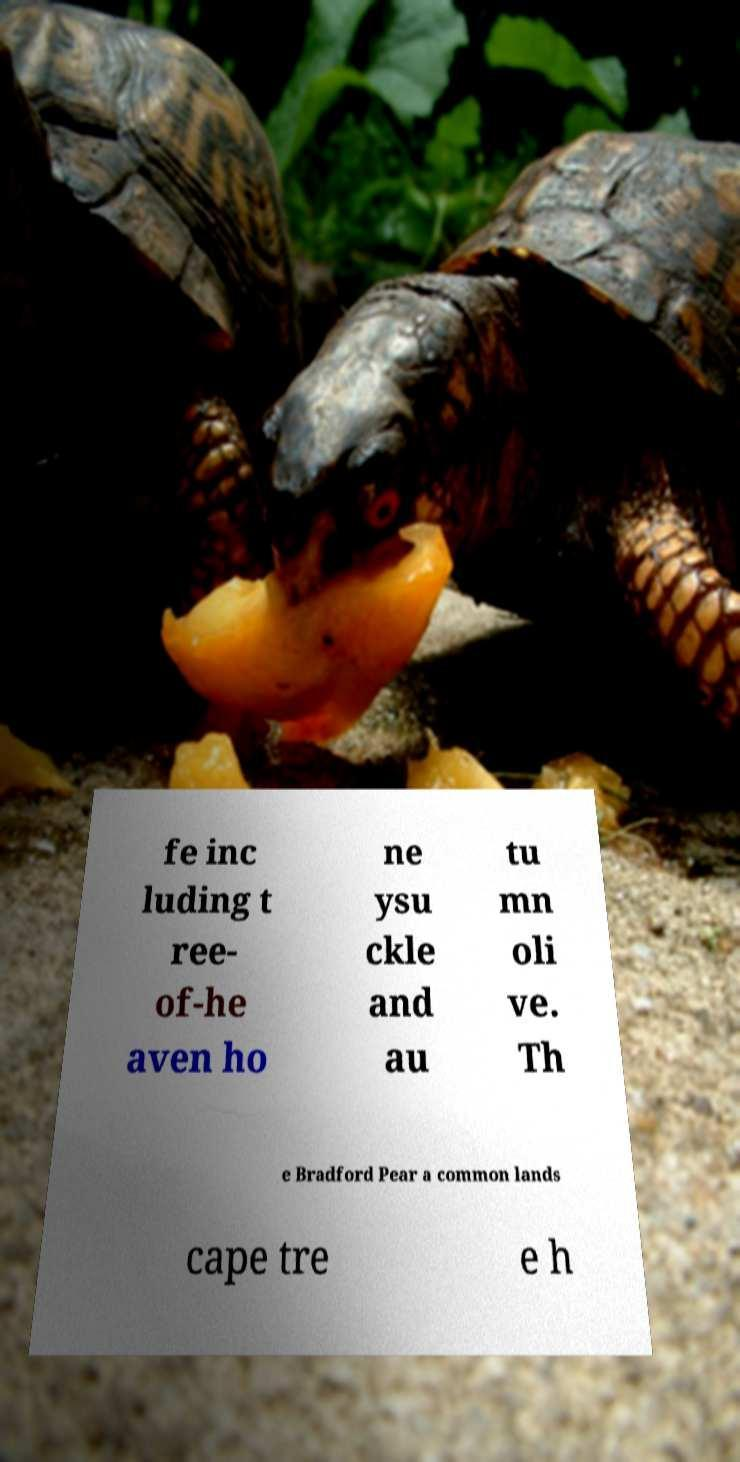For documentation purposes, I need the text within this image transcribed. Could you provide that? fe inc luding t ree- of-he aven ho ne ysu ckle and au tu mn oli ve. Th e Bradford Pear a common lands cape tre e h 